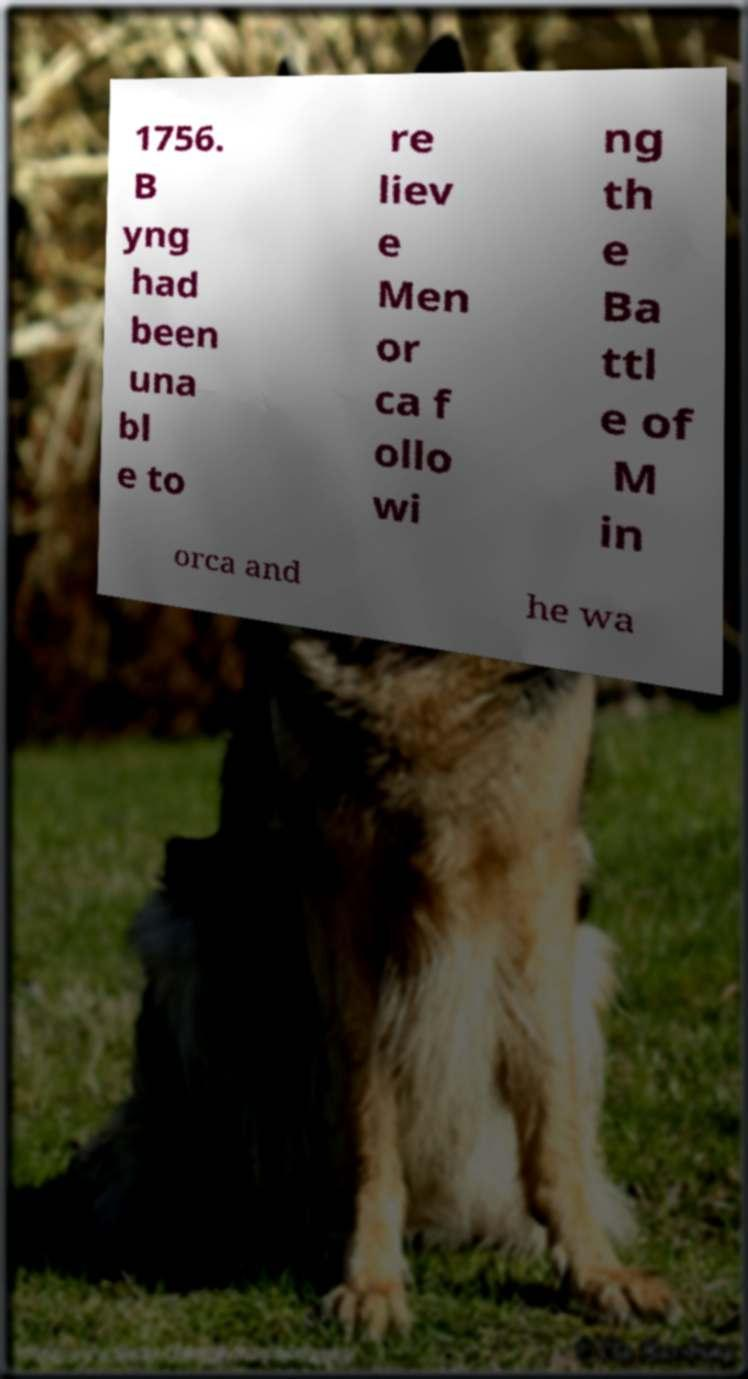For documentation purposes, I need the text within this image transcribed. Could you provide that? 1756. B yng had been una bl e to re liev e Men or ca f ollo wi ng th e Ba ttl e of M in orca and he wa 